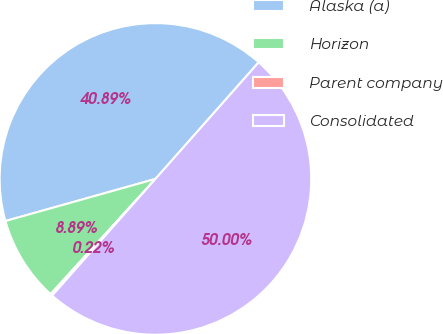Convert chart to OTSL. <chart><loc_0><loc_0><loc_500><loc_500><pie_chart><fcel>Alaska (a)<fcel>Horizon<fcel>Parent company<fcel>Consolidated<nl><fcel>40.89%<fcel>8.89%<fcel>0.22%<fcel>50.0%<nl></chart> 